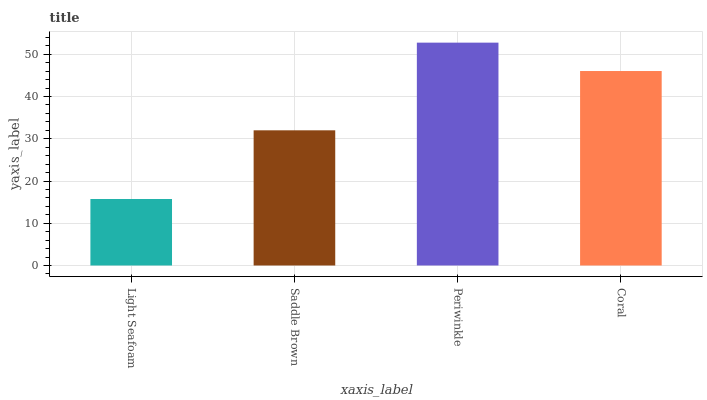Is Light Seafoam the minimum?
Answer yes or no. Yes. Is Periwinkle the maximum?
Answer yes or no. Yes. Is Saddle Brown the minimum?
Answer yes or no. No. Is Saddle Brown the maximum?
Answer yes or no. No. Is Saddle Brown greater than Light Seafoam?
Answer yes or no. Yes. Is Light Seafoam less than Saddle Brown?
Answer yes or no. Yes. Is Light Seafoam greater than Saddle Brown?
Answer yes or no. No. Is Saddle Brown less than Light Seafoam?
Answer yes or no. No. Is Coral the high median?
Answer yes or no. Yes. Is Saddle Brown the low median?
Answer yes or no. Yes. Is Light Seafoam the high median?
Answer yes or no. No. Is Periwinkle the low median?
Answer yes or no. No. 